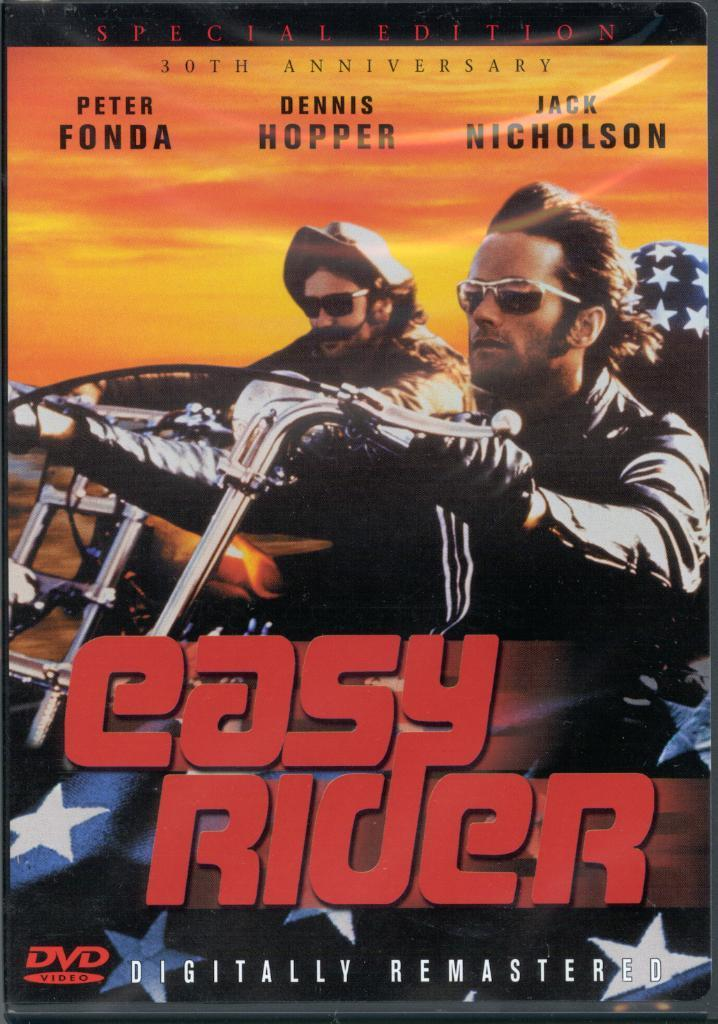<image>
Render a clear and concise summary of the photo. A special edition digitally remastered easy rider movie. 